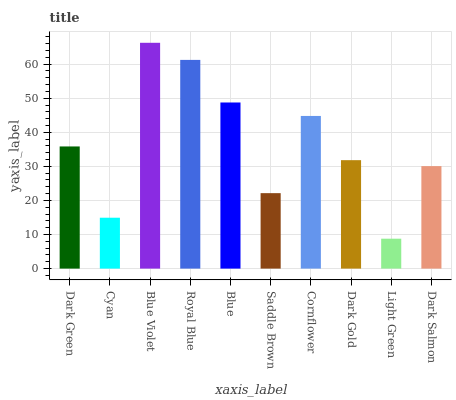Is Light Green the minimum?
Answer yes or no. Yes. Is Blue Violet the maximum?
Answer yes or no. Yes. Is Cyan the minimum?
Answer yes or no. No. Is Cyan the maximum?
Answer yes or no. No. Is Dark Green greater than Cyan?
Answer yes or no. Yes. Is Cyan less than Dark Green?
Answer yes or no. Yes. Is Cyan greater than Dark Green?
Answer yes or no. No. Is Dark Green less than Cyan?
Answer yes or no. No. Is Dark Green the high median?
Answer yes or no. Yes. Is Dark Gold the low median?
Answer yes or no. Yes. Is Royal Blue the high median?
Answer yes or no. No. Is Blue the low median?
Answer yes or no. No. 